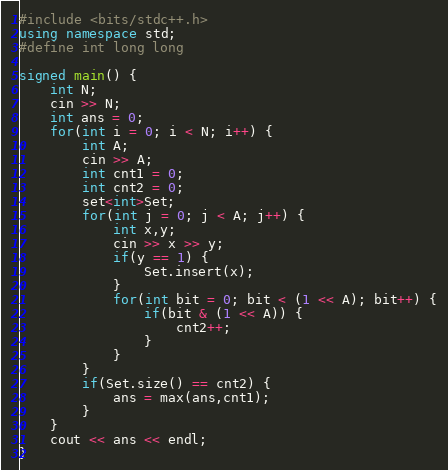<code> <loc_0><loc_0><loc_500><loc_500><_C++_>#include <bits/stdc++.h>
using namespace std;
#define int long long

signed main() {
    int N;
    cin >> N;
    int ans = 0;
    for(int i = 0; i < N; i++) {
        int A;
        cin >> A;
        int cnt1 = 0;
        int cnt2 = 0;
        set<int>Set;
        for(int j = 0; j < A; j++) {
            int x,y;
            cin >> x >> y;
            if(y == 1) {
                Set.insert(x);
            }
            for(int bit = 0; bit < (1 << A); bit++) {
                if(bit & (1 << A)) {
                    cnt2++;
                }
            }
        }
        if(Set.size() == cnt2) {
            ans = max(ans,cnt1);
        }
    }
    cout << ans << endl;
}</code> 